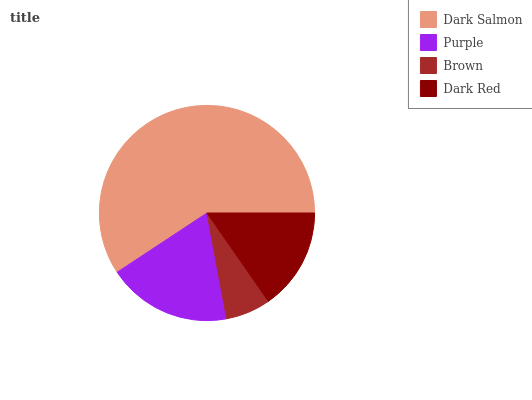Is Brown the minimum?
Answer yes or no. Yes. Is Dark Salmon the maximum?
Answer yes or no. Yes. Is Purple the minimum?
Answer yes or no. No. Is Purple the maximum?
Answer yes or no. No. Is Dark Salmon greater than Purple?
Answer yes or no. Yes. Is Purple less than Dark Salmon?
Answer yes or no. Yes. Is Purple greater than Dark Salmon?
Answer yes or no. No. Is Dark Salmon less than Purple?
Answer yes or no. No. Is Purple the high median?
Answer yes or no. Yes. Is Dark Red the low median?
Answer yes or no. Yes. Is Brown the high median?
Answer yes or no. No. Is Brown the low median?
Answer yes or no. No. 